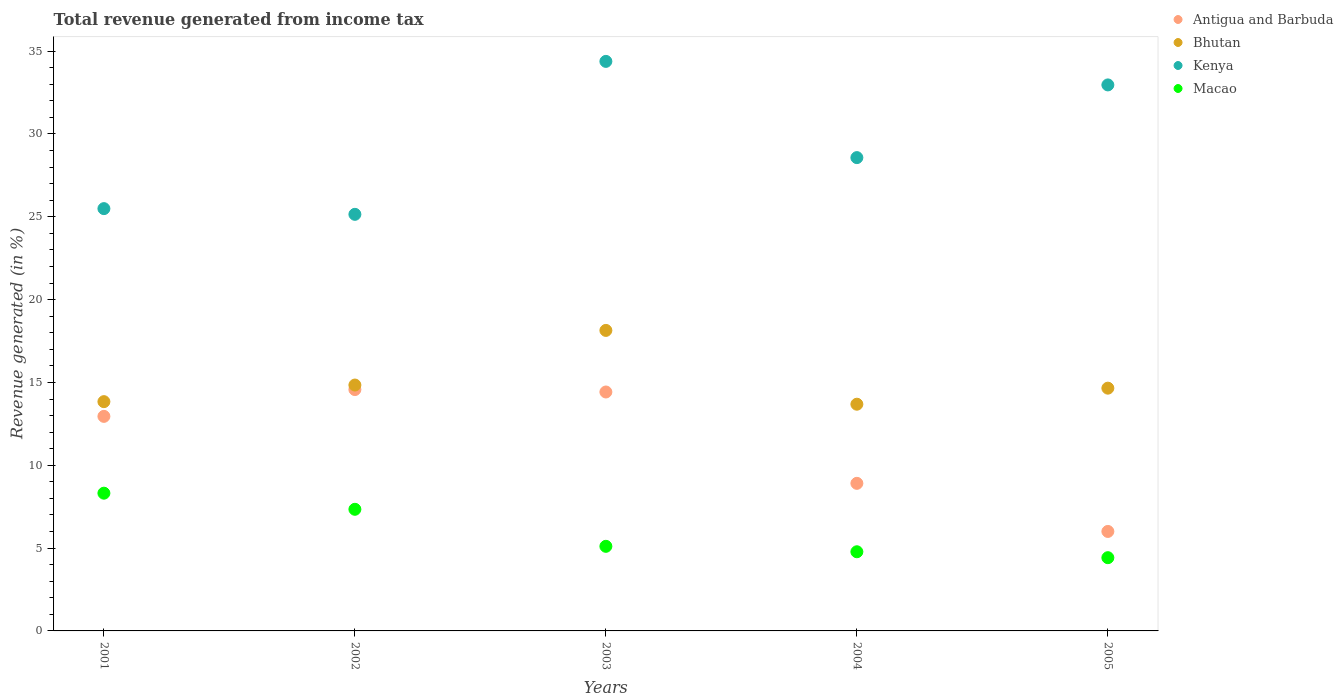How many different coloured dotlines are there?
Your answer should be compact. 4. Is the number of dotlines equal to the number of legend labels?
Your answer should be compact. Yes. What is the total revenue generated in Bhutan in 2004?
Keep it short and to the point. 13.69. Across all years, what is the maximum total revenue generated in Macao?
Make the answer very short. 8.32. Across all years, what is the minimum total revenue generated in Macao?
Ensure brevity in your answer.  4.42. In which year was the total revenue generated in Macao maximum?
Give a very brief answer. 2001. What is the total total revenue generated in Kenya in the graph?
Give a very brief answer. 146.56. What is the difference between the total revenue generated in Bhutan in 2003 and that in 2004?
Make the answer very short. 4.46. What is the difference between the total revenue generated in Antigua and Barbuda in 2004 and the total revenue generated in Kenya in 2001?
Offer a terse response. -16.58. What is the average total revenue generated in Macao per year?
Ensure brevity in your answer.  5.99. In the year 2003, what is the difference between the total revenue generated in Kenya and total revenue generated in Bhutan?
Offer a terse response. 16.24. What is the ratio of the total revenue generated in Macao in 2002 to that in 2005?
Your response must be concise. 1.66. Is the total revenue generated in Antigua and Barbuda in 2004 less than that in 2005?
Your answer should be very brief. No. Is the difference between the total revenue generated in Kenya in 2001 and 2003 greater than the difference between the total revenue generated in Bhutan in 2001 and 2003?
Your answer should be very brief. No. What is the difference between the highest and the second highest total revenue generated in Bhutan?
Your answer should be compact. 3.3. What is the difference between the highest and the lowest total revenue generated in Antigua and Barbuda?
Make the answer very short. 8.57. Does the total revenue generated in Antigua and Barbuda monotonically increase over the years?
Provide a succinct answer. No. How many dotlines are there?
Your response must be concise. 4. Are the values on the major ticks of Y-axis written in scientific E-notation?
Give a very brief answer. No. How many legend labels are there?
Offer a very short reply. 4. How are the legend labels stacked?
Offer a very short reply. Vertical. What is the title of the graph?
Make the answer very short. Total revenue generated from income tax. Does "Iran" appear as one of the legend labels in the graph?
Provide a short and direct response. No. What is the label or title of the Y-axis?
Your response must be concise. Revenue generated (in %). What is the Revenue generated (in %) in Antigua and Barbuda in 2001?
Make the answer very short. 12.95. What is the Revenue generated (in %) in Bhutan in 2001?
Ensure brevity in your answer.  13.84. What is the Revenue generated (in %) in Kenya in 2001?
Your answer should be compact. 25.49. What is the Revenue generated (in %) in Macao in 2001?
Offer a very short reply. 8.32. What is the Revenue generated (in %) in Antigua and Barbuda in 2002?
Your response must be concise. 14.57. What is the Revenue generated (in %) in Bhutan in 2002?
Your response must be concise. 14.84. What is the Revenue generated (in %) of Kenya in 2002?
Your answer should be compact. 25.15. What is the Revenue generated (in %) in Macao in 2002?
Make the answer very short. 7.34. What is the Revenue generated (in %) of Antigua and Barbuda in 2003?
Provide a short and direct response. 14.42. What is the Revenue generated (in %) in Bhutan in 2003?
Ensure brevity in your answer.  18.14. What is the Revenue generated (in %) in Kenya in 2003?
Your answer should be very brief. 34.38. What is the Revenue generated (in %) of Macao in 2003?
Give a very brief answer. 5.11. What is the Revenue generated (in %) of Antigua and Barbuda in 2004?
Provide a short and direct response. 8.91. What is the Revenue generated (in %) of Bhutan in 2004?
Your response must be concise. 13.69. What is the Revenue generated (in %) of Kenya in 2004?
Your response must be concise. 28.57. What is the Revenue generated (in %) of Macao in 2004?
Your response must be concise. 4.78. What is the Revenue generated (in %) in Antigua and Barbuda in 2005?
Provide a succinct answer. 6.01. What is the Revenue generated (in %) of Bhutan in 2005?
Make the answer very short. 14.65. What is the Revenue generated (in %) in Kenya in 2005?
Offer a very short reply. 32.96. What is the Revenue generated (in %) in Macao in 2005?
Offer a very short reply. 4.42. Across all years, what is the maximum Revenue generated (in %) of Antigua and Barbuda?
Make the answer very short. 14.57. Across all years, what is the maximum Revenue generated (in %) of Bhutan?
Give a very brief answer. 18.14. Across all years, what is the maximum Revenue generated (in %) in Kenya?
Provide a succinct answer. 34.38. Across all years, what is the maximum Revenue generated (in %) in Macao?
Give a very brief answer. 8.32. Across all years, what is the minimum Revenue generated (in %) in Antigua and Barbuda?
Your answer should be compact. 6.01. Across all years, what is the minimum Revenue generated (in %) of Bhutan?
Your answer should be very brief. 13.69. Across all years, what is the minimum Revenue generated (in %) in Kenya?
Give a very brief answer. 25.15. Across all years, what is the minimum Revenue generated (in %) in Macao?
Keep it short and to the point. 4.42. What is the total Revenue generated (in %) of Antigua and Barbuda in the graph?
Offer a terse response. 56.86. What is the total Revenue generated (in %) in Bhutan in the graph?
Offer a very short reply. 75.17. What is the total Revenue generated (in %) of Kenya in the graph?
Your answer should be very brief. 146.56. What is the total Revenue generated (in %) of Macao in the graph?
Offer a terse response. 29.96. What is the difference between the Revenue generated (in %) of Antigua and Barbuda in 2001 and that in 2002?
Offer a very short reply. -1.62. What is the difference between the Revenue generated (in %) in Bhutan in 2001 and that in 2002?
Make the answer very short. -1. What is the difference between the Revenue generated (in %) in Kenya in 2001 and that in 2002?
Ensure brevity in your answer.  0.34. What is the difference between the Revenue generated (in %) in Macao in 2001 and that in 2002?
Provide a short and direct response. 0.97. What is the difference between the Revenue generated (in %) of Antigua and Barbuda in 2001 and that in 2003?
Your answer should be very brief. -1.47. What is the difference between the Revenue generated (in %) in Bhutan in 2001 and that in 2003?
Provide a short and direct response. -4.3. What is the difference between the Revenue generated (in %) in Kenya in 2001 and that in 2003?
Keep it short and to the point. -8.89. What is the difference between the Revenue generated (in %) in Macao in 2001 and that in 2003?
Keep it short and to the point. 3.21. What is the difference between the Revenue generated (in %) of Antigua and Barbuda in 2001 and that in 2004?
Your answer should be very brief. 4.04. What is the difference between the Revenue generated (in %) of Bhutan in 2001 and that in 2004?
Offer a terse response. 0.15. What is the difference between the Revenue generated (in %) in Kenya in 2001 and that in 2004?
Your response must be concise. -3.08. What is the difference between the Revenue generated (in %) in Macao in 2001 and that in 2004?
Keep it short and to the point. 3.54. What is the difference between the Revenue generated (in %) of Antigua and Barbuda in 2001 and that in 2005?
Offer a terse response. 6.95. What is the difference between the Revenue generated (in %) in Bhutan in 2001 and that in 2005?
Ensure brevity in your answer.  -0.81. What is the difference between the Revenue generated (in %) of Kenya in 2001 and that in 2005?
Offer a very short reply. -7.47. What is the difference between the Revenue generated (in %) of Macao in 2001 and that in 2005?
Your response must be concise. 3.89. What is the difference between the Revenue generated (in %) in Antigua and Barbuda in 2002 and that in 2003?
Provide a succinct answer. 0.15. What is the difference between the Revenue generated (in %) in Bhutan in 2002 and that in 2003?
Make the answer very short. -3.3. What is the difference between the Revenue generated (in %) in Kenya in 2002 and that in 2003?
Provide a succinct answer. -9.23. What is the difference between the Revenue generated (in %) of Macao in 2002 and that in 2003?
Offer a very short reply. 2.23. What is the difference between the Revenue generated (in %) in Antigua and Barbuda in 2002 and that in 2004?
Your response must be concise. 5.66. What is the difference between the Revenue generated (in %) in Bhutan in 2002 and that in 2004?
Make the answer very short. 1.16. What is the difference between the Revenue generated (in %) in Kenya in 2002 and that in 2004?
Ensure brevity in your answer.  -3.42. What is the difference between the Revenue generated (in %) of Macao in 2002 and that in 2004?
Offer a terse response. 2.56. What is the difference between the Revenue generated (in %) of Antigua and Barbuda in 2002 and that in 2005?
Your answer should be very brief. 8.57. What is the difference between the Revenue generated (in %) in Bhutan in 2002 and that in 2005?
Offer a very short reply. 0.19. What is the difference between the Revenue generated (in %) of Kenya in 2002 and that in 2005?
Make the answer very short. -7.81. What is the difference between the Revenue generated (in %) of Macao in 2002 and that in 2005?
Offer a very short reply. 2.92. What is the difference between the Revenue generated (in %) of Antigua and Barbuda in 2003 and that in 2004?
Your response must be concise. 5.51. What is the difference between the Revenue generated (in %) in Bhutan in 2003 and that in 2004?
Keep it short and to the point. 4.46. What is the difference between the Revenue generated (in %) of Kenya in 2003 and that in 2004?
Your answer should be compact. 5.81. What is the difference between the Revenue generated (in %) in Macao in 2003 and that in 2004?
Provide a succinct answer. 0.33. What is the difference between the Revenue generated (in %) of Antigua and Barbuda in 2003 and that in 2005?
Give a very brief answer. 8.42. What is the difference between the Revenue generated (in %) in Bhutan in 2003 and that in 2005?
Provide a succinct answer. 3.49. What is the difference between the Revenue generated (in %) of Kenya in 2003 and that in 2005?
Offer a terse response. 1.42. What is the difference between the Revenue generated (in %) in Macao in 2003 and that in 2005?
Offer a very short reply. 0.69. What is the difference between the Revenue generated (in %) of Antigua and Barbuda in 2004 and that in 2005?
Give a very brief answer. 2.9. What is the difference between the Revenue generated (in %) in Bhutan in 2004 and that in 2005?
Provide a short and direct response. -0.97. What is the difference between the Revenue generated (in %) of Kenya in 2004 and that in 2005?
Provide a succinct answer. -4.39. What is the difference between the Revenue generated (in %) of Macao in 2004 and that in 2005?
Provide a succinct answer. 0.36. What is the difference between the Revenue generated (in %) in Antigua and Barbuda in 2001 and the Revenue generated (in %) in Bhutan in 2002?
Your response must be concise. -1.89. What is the difference between the Revenue generated (in %) in Antigua and Barbuda in 2001 and the Revenue generated (in %) in Kenya in 2002?
Your answer should be very brief. -12.2. What is the difference between the Revenue generated (in %) of Antigua and Barbuda in 2001 and the Revenue generated (in %) of Macao in 2002?
Provide a succinct answer. 5.61. What is the difference between the Revenue generated (in %) in Bhutan in 2001 and the Revenue generated (in %) in Kenya in 2002?
Offer a terse response. -11.31. What is the difference between the Revenue generated (in %) in Bhutan in 2001 and the Revenue generated (in %) in Macao in 2002?
Make the answer very short. 6.5. What is the difference between the Revenue generated (in %) in Kenya in 2001 and the Revenue generated (in %) in Macao in 2002?
Provide a succinct answer. 18.15. What is the difference between the Revenue generated (in %) in Antigua and Barbuda in 2001 and the Revenue generated (in %) in Bhutan in 2003?
Make the answer very short. -5.19. What is the difference between the Revenue generated (in %) of Antigua and Barbuda in 2001 and the Revenue generated (in %) of Kenya in 2003?
Your answer should be very brief. -21.43. What is the difference between the Revenue generated (in %) in Antigua and Barbuda in 2001 and the Revenue generated (in %) in Macao in 2003?
Your response must be concise. 7.85. What is the difference between the Revenue generated (in %) in Bhutan in 2001 and the Revenue generated (in %) in Kenya in 2003?
Keep it short and to the point. -20.54. What is the difference between the Revenue generated (in %) of Bhutan in 2001 and the Revenue generated (in %) of Macao in 2003?
Offer a very short reply. 8.73. What is the difference between the Revenue generated (in %) in Kenya in 2001 and the Revenue generated (in %) in Macao in 2003?
Your response must be concise. 20.39. What is the difference between the Revenue generated (in %) of Antigua and Barbuda in 2001 and the Revenue generated (in %) of Bhutan in 2004?
Ensure brevity in your answer.  -0.73. What is the difference between the Revenue generated (in %) in Antigua and Barbuda in 2001 and the Revenue generated (in %) in Kenya in 2004?
Ensure brevity in your answer.  -15.62. What is the difference between the Revenue generated (in %) in Antigua and Barbuda in 2001 and the Revenue generated (in %) in Macao in 2004?
Your answer should be compact. 8.17. What is the difference between the Revenue generated (in %) in Bhutan in 2001 and the Revenue generated (in %) in Kenya in 2004?
Make the answer very short. -14.73. What is the difference between the Revenue generated (in %) in Bhutan in 2001 and the Revenue generated (in %) in Macao in 2004?
Provide a short and direct response. 9.06. What is the difference between the Revenue generated (in %) of Kenya in 2001 and the Revenue generated (in %) of Macao in 2004?
Keep it short and to the point. 20.71. What is the difference between the Revenue generated (in %) of Antigua and Barbuda in 2001 and the Revenue generated (in %) of Bhutan in 2005?
Ensure brevity in your answer.  -1.7. What is the difference between the Revenue generated (in %) of Antigua and Barbuda in 2001 and the Revenue generated (in %) of Kenya in 2005?
Provide a succinct answer. -20.01. What is the difference between the Revenue generated (in %) in Antigua and Barbuda in 2001 and the Revenue generated (in %) in Macao in 2005?
Keep it short and to the point. 8.53. What is the difference between the Revenue generated (in %) of Bhutan in 2001 and the Revenue generated (in %) of Kenya in 2005?
Your response must be concise. -19.12. What is the difference between the Revenue generated (in %) of Bhutan in 2001 and the Revenue generated (in %) of Macao in 2005?
Your response must be concise. 9.42. What is the difference between the Revenue generated (in %) of Kenya in 2001 and the Revenue generated (in %) of Macao in 2005?
Provide a succinct answer. 21.07. What is the difference between the Revenue generated (in %) of Antigua and Barbuda in 2002 and the Revenue generated (in %) of Bhutan in 2003?
Offer a terse response. -3.57. What is the difference between the Revenue generated (in %) in Antigua and Barbuda in 2002 and the Revenue generated (in %) in Kenya in 2003?
Your response must be concise. -19.81. What is the difference between the Revenue generated (in %) of Antigua and Barbuda in 2002 and the Revenue generated (in %) of Macao in 2003?
Your response must be concise. 9.46. What is the difference between the Revenue generated (in %) of Bhutan in 2002 and the Revenue generated (in %) of Kenya in 2003?
Offer a terse response. -19.54. What is the difference between the Revenue generated (in %) of Bhutan in 2002 and the Revenue generated (in %) of Macao in 2003?
Offer a terse response. 9.74. What is the difference between the Revenue generated (in %) in Kenya in 2002 and the Revenue generated (in %) in Macao in 2003?
Make the answer very short. 20.04. What is the difference between the Revenue generated (in %) of Antigua and Barbuda in 2002 and the Revenue generated (in %) of Bhutan in 2004?
Your response must be concise. 0.88. What is the difference between the Revenue generated (in %) of Antigua and Barbuda in 2002 and the Revenue generated (in %) of Kenya in 2004?
Your answer should be compact. -14. What is the difference between the Revenue generated (in %) in Antigua and Barbuda in 2002 and the Revenue generated (in %) in Macao in 2004?
Make the answer very short. 9.79. What is the difference between the Revenue generated (in %) of Bhutan in 2002 and the Revenue generated (in %) of Kenya in 2004?
Your answer should be compact. -13.73. What is the difference between the Revenue generated (in %) of Bhutan in 2002 and the Revenue generated (in %) of Macao in 2004?
Keep it short and to the point. 10.06. What is the difference between the Revenue generated (in %) in Kenya in 2002 and the Revenue generated (in %) in Macao in 2004?
Ensure brevity in your answer.  20.37. What is the difference between the Revenue generated (in %) in Antigua and Barbuda in 2002 and the Revenue generated (in %) in Bhutan in 2005?
Provide a short and direct response. -0.08. What is the difference between the Revenue generated (in %) of Antigua and Barbuda in 2002 and the Revenue generated (in %) of Kenya in 2005?
Offer a terse response. -18.39. What is the difference between the Revenue generated (in %) of Antigua and Barbuda in 2002 and the Revenue generated (in %) of Macao in 2005?
Ensure brevity in your answer.  10.15. What is the difference between the Revenue generated (in %) of Bhutan in 2002 and the Revenue generated (in %) of Kenya in 2005?
Offer a very short reply. -18.12. What is the difference between the Revenue generated (in %) of Bhutan in 2002 and the Revenue generated (in %) of Macao in 2005?
Your response must be concise. 10.42. What is the difference between the Revenue generated (in %) of Kenya in 2002 and the Revenue generated (in %) of Macao in 2005?
Your answer should be very brief. 20.73. What is the difference between the Revenue generated (in %) in Antigua and Barbuda in 2003 and the Revenue generated (in %) in Bhutan in 2004?
Ensure brevity in your answer.  0.74. What is the difference between the Revenue generated (in %) in Antigua and Barbuda in 2003 and the Revenue generated (in %) in Kenya in 2004?
Make the answer very short. -14.15. What is the difference between the Revenue generated (in %) of Antigua and Barbuda in 2003 and the Revenue generated (in %) of Macao in 2004?
Your answer should be compact. 9.65. What is the difference between the Revenue generated (in %) of Bhutan in 2003 and the Revenue generated (in %) of Kenya in 2004?
Make the answer very short. -10.43. What is the difference between the Revenue generated (in %) of Bhutan in 2003 and the Revenue generated (in %) of Macao in 2004?
Keep it short and to the point. 13.36. What is the difference between the Revenue generated (in %) of Kenya in 2003 and the Revenue generated (in %) of Macao in 2004?
Make the answer very short. 29.6. What is the difference between the Revenue generated (in %) of Antigua and Barbuda in 2003 and the Revenue generated (in %) of Bhutan in 2005?
Offer a terse response. -0.23. What is the difference between the Revenue generated (in %) in Antigua and Barbuda in 2003 and the Revenue generated (in %) in Kenya in 2005?
Provide a short and direct response. -18.54. What is the difference between the Revenue generated (in %) in Antigua and Barbuda in 2003 and the Revenue generated (in %) in Macao in 2005?
Keep it short and to the point. 10. What is the difference between the Revenue generated (in %) in Bhutan in 2003 and the Revenue generated (in %) in Kenya in 2005?
Provide a succinct answer. -14.82. What is the difference between the Revenue generated (in %) of Bhutan in 2003 and the Revenue generated (in %) of Macao in 2005?
Make the answer very short. 13.72. What is the difference between the Revenue generated (in %) in Kenya in 2003 and the Revenue generated (in %) in Macao in 2005?
Keep it short and to the point. 29.96. What is the difference between the Revenue generated (in %) of Antigua and Barbuda in 2004 and the Revenue generated (in %) of Bhutan in 2005?
Give a very brief answer. -5.75. What is the difference between the Revenue generated (in %) in Antigua and Barbuda in 2004 and the Revenue generated (in %) in Kenya in 2005?
Your answer should be compact. -24.05. What is the difference between the Revenue generated (in %) in Antigua and Barbuda in 2004 and the Revenue generated (in %) in Macao in 2005?
Offer a terse response. 4.49. What is the difference between the Revenue generated (in %) of Bhutan in 2004 and the Revenue generated (in %) of Kenya in 2005?
Offer a very short reply. -19.28. What is the difference between the Revenue generated (in %) in Bhutan in 2004 and the Revenue generated (in %) in Macao in 2005?
Make the answer very short. 9.26. What is the difference between the Revenue generated (in %) in Kenya in 2004 and the Revenue generated (in %) in Macao in 2005?
Your answer should be very brief. 24.15. What is the average Revenue generated (in %) in Antigua and Barbuda per year?
Keep it short and to the point. 11.37. What is the average Revenue generated (in %) in Bhutan per year?
Your response must be concise. 15.03. What is the average Revenue generated (in %) in Kenya per year?
Offer a very short reply. 29.31. What is the average Revenue generated (in %) of Macao per year?
Provide a short and direct response. 5.99. In the year 2001, what is the difference between the Revenue generated (in %) in Antigua and Barbuda and Revenue generated (in %) in Bhutan?
Make the answer very short. -0.89. In the year 2001, what is the difference between the Revenue generated (in %) of Antigua and Barbuda and Revenue generated (in %) of Kenya?
Give a very brief answer. -12.54. In the year 2001, what is the difference between the Revenue generated (in %) in Antigua and Barbuda and Revenue generated (in %) in Macao?
Provide a short and direct response. 4.64. In the year 2001, what is the difference between the Revenue generated (in %) of Bhutan and Revenue generated (in %) of Kenya?
Your answer should be compact. -11.65. In the year 2001, what is the difference between the Revenue generated (in %) of Bhutan and Revenue generated (in %) of Macao?
Ensure brevity in your answer.  5.53. In the year 2001, what is the difference between the Revenue generated (in %) of Kenya and Revenue generated (in %) of Macao?
Offer a terse response. 17.18. In the year 2002, what is the difference between the Revenue generated (in %) of Antigua and Barbuda and Revenue generated (in %) of Bhutan?
Provide a succinct answer. -0.27. In the year 2002, what is the difference between the Revenue generated (in %) in Antigua and Barbuda and Revenue generated (in %) in Kenya?
Provide a succinct answer. -10.58. In the year 2002, what is the difference between the Revenue generated (in %) of Antigua and Barbuda and Revenue generated (in %) of Macao?
Ensure brevity in your answer.  7.23. In the year 2002, what is the difference between the Revenue generated (in %) of Bhutan and Revenue generated (in %) of Kenya?
Your answer should be compact. -10.31. In the year 2002, what is the difference between the Revenue generated (in %) in Bhutan and Revenue generated (in %) in Macao?
Your answer should be very brief. 7.5. In the year 2002, what is the difference between the Revenue generated (in %) of Kenya and Revenue generated (in %) of Macao?
Provide a short and direct response. 17.81. In the year 2003, what is the difference between the Revenue generated (in %) in Antigua and Barbuda and Revenue generated (in %) in Bhutan?
Your answer should be compact. -3.72. In the year 2003, what is the difference between the Revenue generated (in %) of Antigua and Barbuda and Revenue generated (in %) of Kenya?
Your response must be concise. -19.96. In the year 2003, what is the difference between the Revenue generated (in %) of Antigua and Barbuda and Revenue generated (in %) of Macao?
Make the answer very short. 9.32. In the year 2003, what is the difference between the Revenue generated (in %) in Bhutan and Revenue generated (in %) in Kenya?
Offer a very short reply. -16.24. In the year 2003, what is the difference between the Revenue generated (in %) of Bhutan and Revenue generated (in %) of Macao?
Give a very brief answer. 13.03. In the year 2003, what is the difference between the Revenue generated (in %) in Kenya and Revenue generated (in %) in Macao?
Your answer should be compact. 29.27. In the year 2004, what is the difference between the Revenue generated (in %) in Antigua and Barbuda and Revenue generated (in %) in Bhutan?
Make the answer very short. -4.78. In the year 2004, what is the difference between the Revenue generated (in %) in Antigua and Barbuda and Revenue generated (in %) in Kenya?
Ensure brevity in your answer.  -19.66. In the year 2004, what is the difference between the Revenue generated (in %) of Antigua and Barbuda and Revenue generated (in %) of Macao?
Provide a short and direct response. 4.13. In the year 2004, what is the difference between the Revenue generated (in %) in Bhutan and Revenue generated (in %) in Kenya?
Offer a very short reply. -14.89. In the year 2004, what is the difference between the Revenue generated (in %) of Bhutan and Revenue generated (in %) of Macao?
Provide a succinct answer. 8.91. In the year 2004, what is the difference between the Revenue generated (in %) of Kenya and Revenue generated (in %) of Macao?
Your answer should be compact. 23.79. In the year 2005, what is the difference between the Revenue generated (in %) of Antigua and Barbuda and Revenue generated (in %) of Bhutan?
Keep it short and to the point. -8.65. In the year 2005, what is the difference between the Revenue generated (in %) in Antigua and Barbuda and Revenue generated (in %) in Kenya?
Offer a very short reply. -26.96. In the year 2005, what is the difference between the Revenue generated (in %) in Antigua and Barbuda and Revenue generated (in %) in Macao?
Your response must be concise. 1.58. In the year 2005, what is the difference between the Revenue generated (in %) of Bhutan and Revenue generated (in %) of Kenya?
Provide a succinct answer. -18.31. In the year 2005, what is the difference between the Revenue generated (in %) in Bhutan and Revenue generated (in %) in Macao?
Make the answer very short. 10.23. In the year 2005, what is the difference between the Revenue generated (in %) in Kenya and Revenue generated (in %) in Macao?
Your answer should be very brief. 28.54. What is the ratio of the Revenue generated (in %) in Bhutan in 2001 to that in 2002?
Your answer should be very brief. 0.93. What is the ratio of the Revenue generated (in %) in Kenya in 2001 to that in 2002?
Offer a terse response. 1.01. What is the ratio of the Revenue generated (in %) of Macao in 2001 to that in 2002?
Provide a succinct answer. 1.13. What is the ratio of the Revenue generated (in %) in Antigua and Barbuda in 2001 to that in 2003?
Your answer should be very brief. 0.9. What is the ratio of the Revenue generated (in %) of Bhutan in 2001 to that in 2003?
Offer a very short reply. 0.76. What is the ratio of the Revenue generated (in %) of Kenya in 2001 to that in 2003?
Give a very brief answer. 0.74. What is the ratio of the Revenue generated (in %) in Macao in 2001 to that in 2003?
Ensure brevity in your answer.  1.63. What is the ratio of the Revenue generated (in %) in Antigua and Barbuda in 2001 to that in 2004?
Your answer should be compact. 1.45. What is the ratio of the Revenue generated (in %) of Bhutan in 2001 to that in 2004?
Give a very brief answer. 1.01. What is the ratio of the Revenue generated (in %) of Kenya in 2001 to that in 2004?
Keep it short and to the point. 0.89. What is the ratio of the Revenue generated (in %) of Macao in 2001 to that in 2004?
Give a very brief answer. 1.74. What is the ratio of the Revenue generated (in %) in Antigua and Barbuda in 2001 to that in 2005?
Provide a short and direct response. 2.16. What is the ratio of the Revenue generated (in %) of Bhutan in 2001 to that in 2005?
Make the answer very short. 0.94. What is the ratio of the Revenue generated (in %) in Kenya in 2001 to that in 2005?
Provide a succinct answer. 0.77. What is the ratio of the Revenue generated (in %) of Macao in 2001 to that in 2005?
Ensure brevity in your answer.  1.88. What is the ratio of the Revenue generated (in %) in Antigua and Barbuda in 2002 to that in 2003?
Provide a succinct answer. 1.01. What is the ratio of the Revenue generated (in %) of Bhutan in 2002 to that in 2003?
Keep it short and to the point. 0.82. What is the ratio of the Revenue generated (in %) of Kenya in 2002 to that in 2003?
Your answer should be very brief. 0.73. What is the ratio of the Revenue generated (in %) of Macao in 2002 to that in 2003?
Your response must be concise. 1.44. What is the ratio of the Revenue generated (in %) in Antigua and Barbuda in 2002 to that in 2004?
Offer a terse response. 1.64. What is the ratio of the Revenue generated (in %) in Bhutan in 2002 to that in 2004?
Your answer should be compact. 1.08. What is the ratio of the Revenue generated (in %) in Kenya in 2002 to that in 2004?
Give a very brief answer. 0.88. What is the ratio of the Revenue generated (in %) in Macao in 2002 to that in 2004?
Provide a short and direct response. 1.54. What is the ratio of the Revenue generated (in %) in Antigua and Barbuda in 2002 to that in 2005?
Offer a very short reply. 2.43. What is the ratio of the Revenue generated (in %) in Bhutan in 2002 to that in 2005?
Give a very brief answer. 1.01. What is the ratio of the Revenue generated (in %) of Kenya in 2002 to that in 2005?
Provide a short and direct response. 0.76. What is the ratio of the Revenue generated (in %) in Macao in 2002 to that in 2005?
Give a very brief answer. 1.66. What is the ratio of the Revenue generated (in %) of Antigua and Barbuda in 2003 to that in 2004?
Provide a succinct answer. 1.62. What is the ratio of the Revenue generated (in %) in Bhutan in 2003 to that in 2004?
Your answer should be very brief. 1.33. What is the ratio of the Revenue generated (in %) in Kenya in 2003 to that in 2004?
Make the answer very short. 1.2. What is the ratio of the Revenue generated (in %) in Macao in 2003 to that in 2004?
Provide a succinct answer. 1.07. What is the ratio of the Revenue generated (in %) of Antigua and Barbuda in 2003 to that in 2005?
Give a very brief answer. 2.4. What is the ratio of the Revenue generated (in %) in Bhutan in 2003 to that in 2005?
Your response must be concise. 1.24. What is the ratio of the Revenue generated (in %) in Kenya in 2003 to that in 2005?
Provide a short and direct response. 1.04. What is the ratio of the Revenue generated (in %) in Macao in 2003 to that in 2005?
Your answer should be very brief. 1.16. What is the ratio of the Revenue generated (in %) of Antigua and Barbuda in 2004 to that in 2005?
Your response must be concise. 1.48. What is the ratio of the Revenue generated (in %) in Bhutan in 2004 to that in 2005?
Give a very brief answer. 0.93. What is the ratio of the Revenue generated (in %) in Kenya in 2004 to that in 2005?
Your response must be concise. 0.87. What is the ratio of the Revenue generated (in %) of Macao in 2004 to that in 2005?
Offer a very short reply. 1.08. What is the difference between the highest and the second highest Revenue generated (in %) in Antigua and Barbuda?
Provide a short and direct response. 0.15. What is the difference between the highest and the second highest Revenue generated (in %) in Bhutan?
Keep it short and to the point. 3.3. What is the difference between the highest and the second highest Revenue generated (in %) of Kenya?
Make the answer very short. 1.42. What is the difference between the highest and the second highest Revenue generated (in %) of Macao?
Offer a terse response. 0.97. What is the difference between the highest and the lowest Revenue generated (in %) of Antigua and Barbuda?
Make the answer very short. 8.57. What is the difference between the highest and the lowest Revenue generated (in %) of Bhutan?
Your answer should be very brief. 4.46. What is the difference between the highest and the lowest Revenue generated (in %) in Kenya?
Make the answer very short. 9.23. What is the difference between the highest and the lowest Revenue generated (in %) of Macao?
Your answer should be compact. 3.89. 